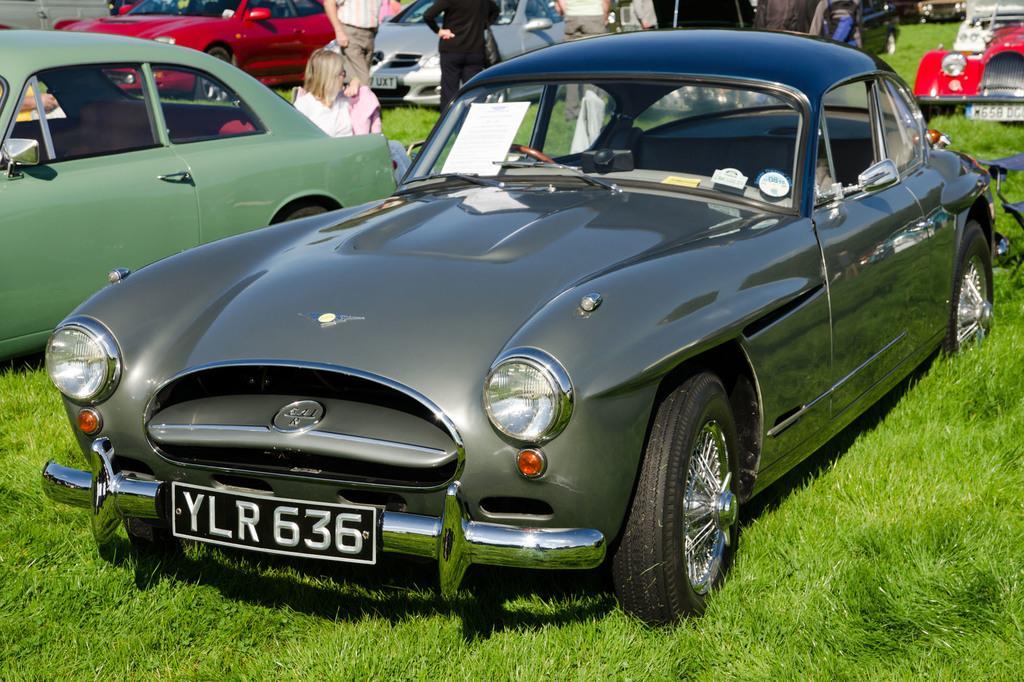In one or two sentences, can you explain what this image depicts? This picture is clicked outside. In the foreground we can see the green grass and there are some vehicles parked on the ground. In the background we can see the group of persons. 